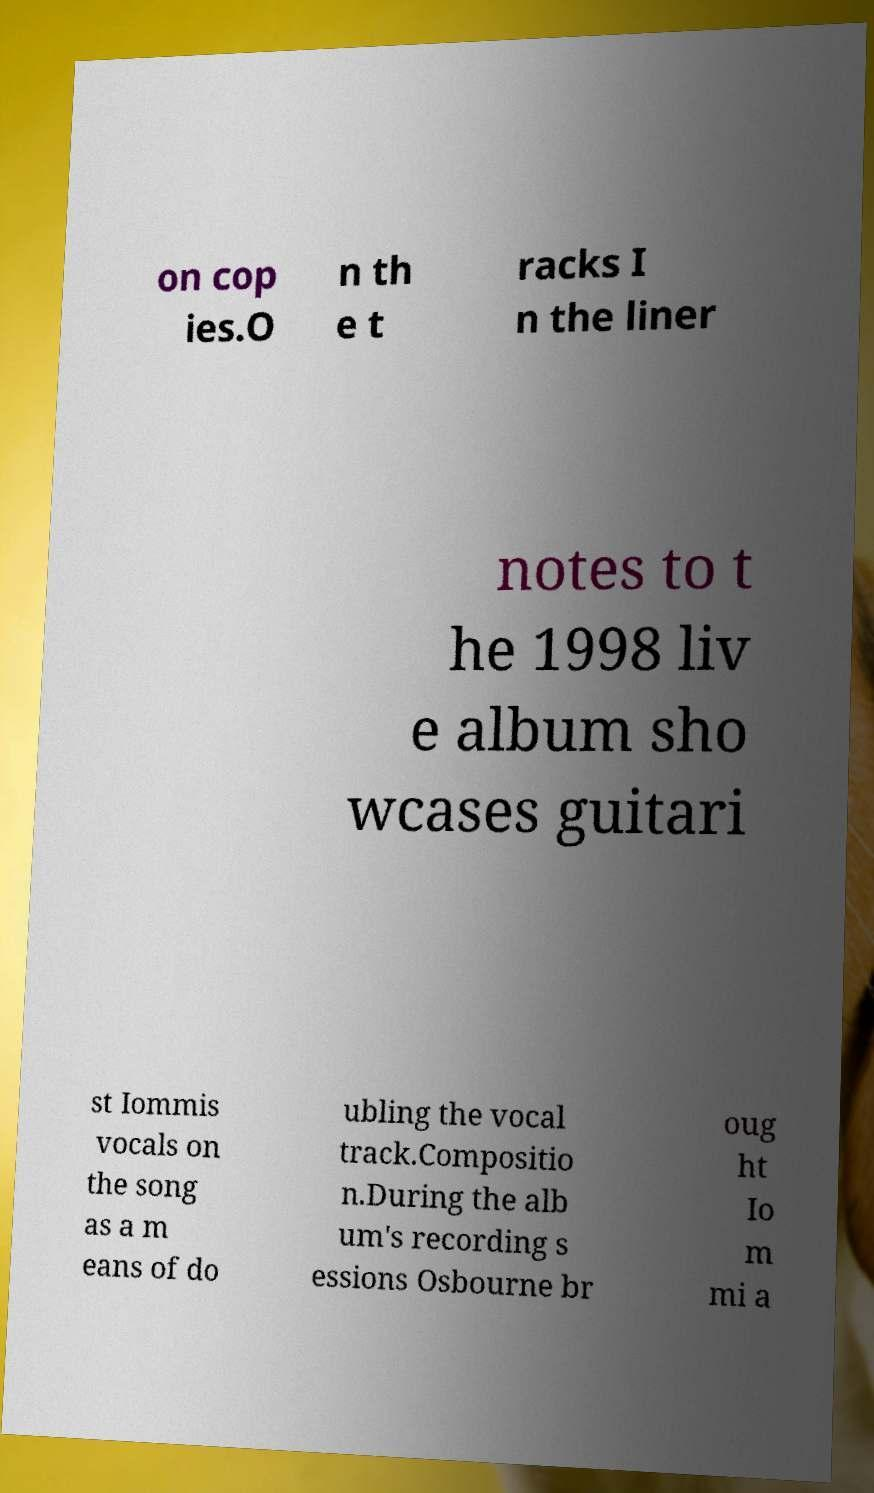Can you accurately transcribe the text from the provided image for me? on cop ies.O n th e t racks I n the liner notes to t he 1998 liv e album sho wcases guitari st Iommis vocals on the song as a m eans of do ubling the vocal track.Compositio n.During the alb um's recording s essions Osbourne br oug ht Io m mi a 